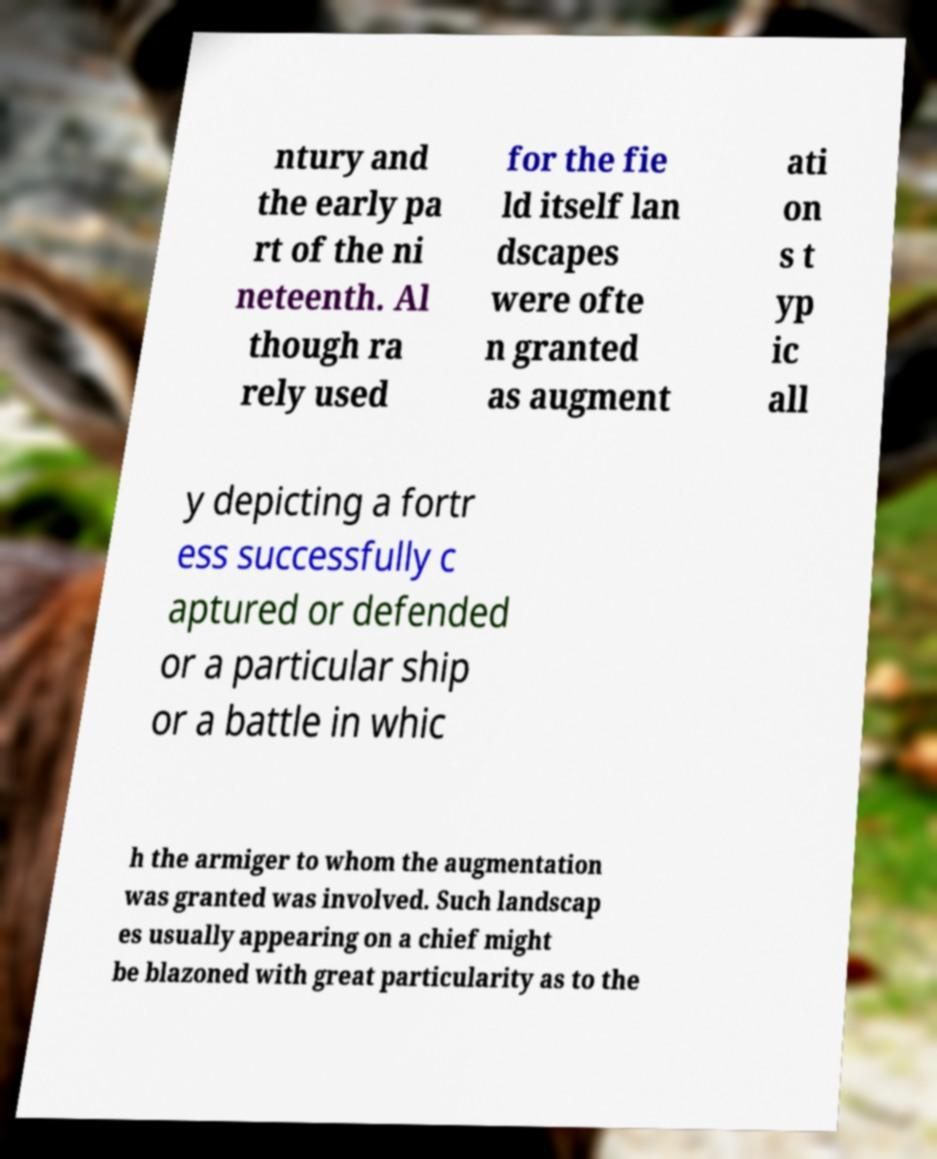I need the written content from this picture converted into text. Can you do that? ntury and the early pa rt of the ni neteenth. Al though ra rely used for the fie ld itself lan dscapes were ofte n granted as augment ati on s t yp ic all y depicting a fortr ess successfully c aptured or defended or a particular ship or a battle in whic h the armiger to whom the augmentation was granted was involved. Such landscap es usually appearing on a chief might be blazoned with great particularity as to the 